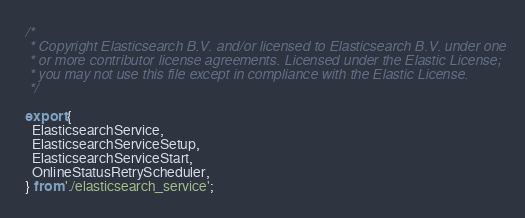<code> <loc_0><loc_0><loc_500><loc_500><_TypeScript_>/*
 * Copyright Elasticsearch B.V. and/or licensed to Elasticsearch B.V. under one
 * or more contributor license agreements. Licensed under the Elastic License;
 * you may not use this file except in compliance with the Elastic License.
 */

export {
  ElasticsearchService,
  ElasticsearchServiceSetup,
  ElasticsearchServiceStart,
  OnlineStatusRetryScheduler,
} from './elasticsearch_service';
</code> 